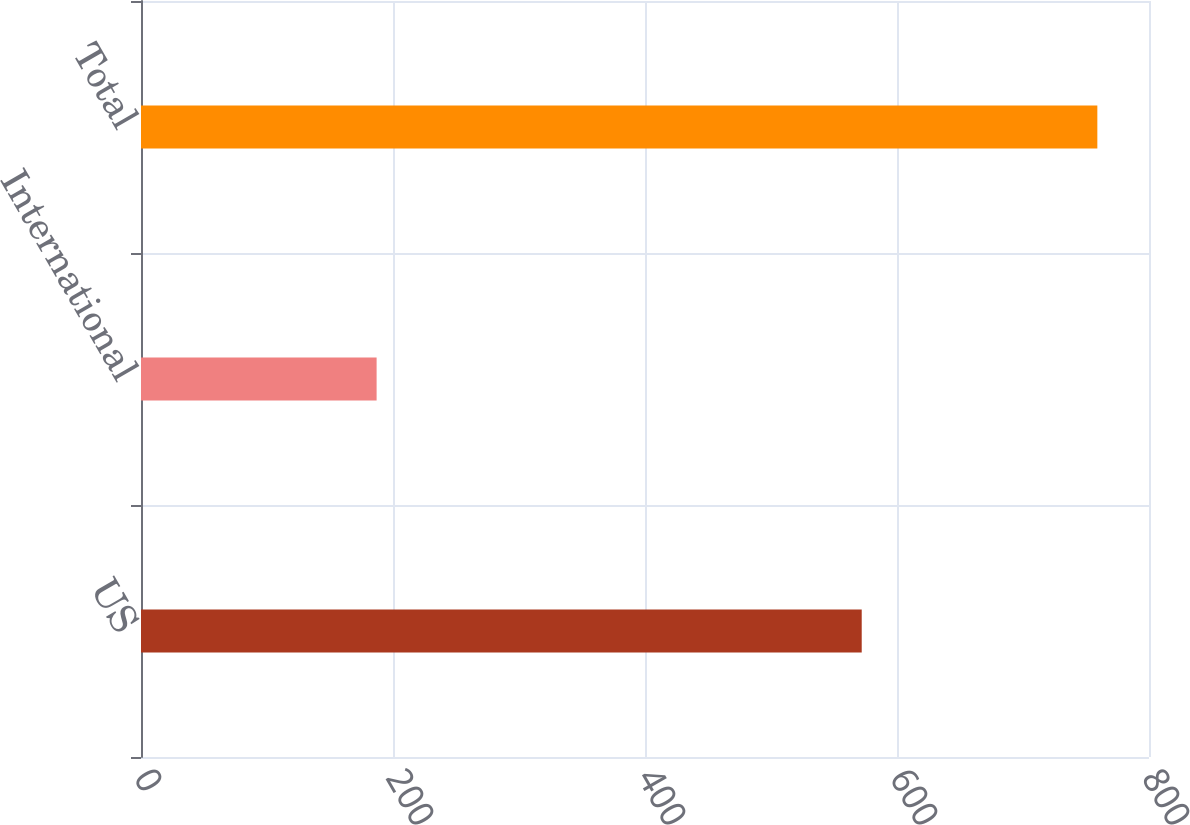<chart> <loc_0><loc_0><loc_500><loc_500><bar_chart><fcel>US<fcel>International<fcel>Total<nl><fcel>572<fcel>187<fcel>759<nl></chart> 